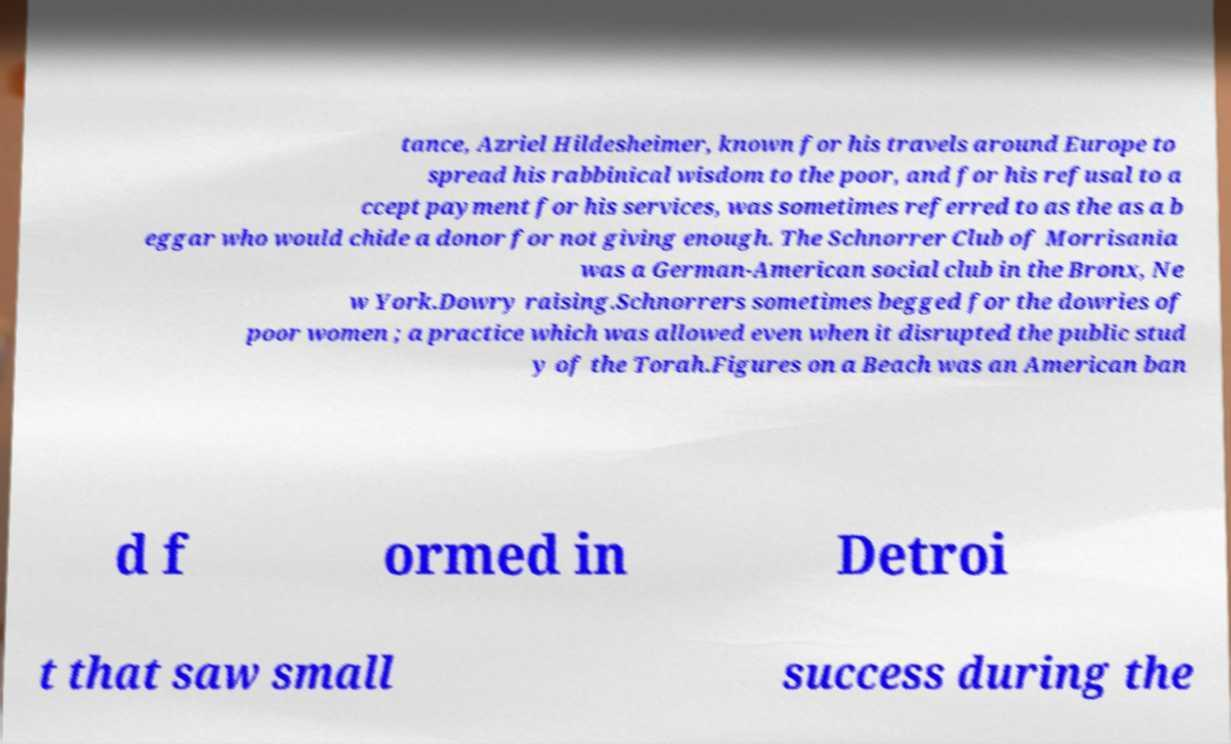Please identify and transcribe the text found in this image. tance, Azriel Hildesheimer, known for his travels around Europe to spread his rabbinical wisdom to the poor, and for his refusal to a ccept payment for his services, was sometimes referred to as the as a b eggar who would chide a donor for not giving enough. The Schnorrer Club of Morrisania was a German-American social club in the Bronx, Ne w York.Dowry raising.Schnorrers sometimes begged for the dowries of poor women ; a practice which was allowed even when it disrupted the public stud y of the Torah.Figures on a Beach was an American ban d f ormed in Detroi t that saw small success during the 